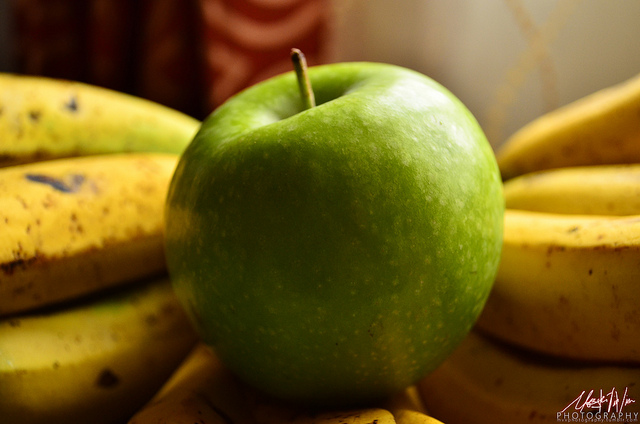Read and extract the text from this image. PHOTOGRAPHY 